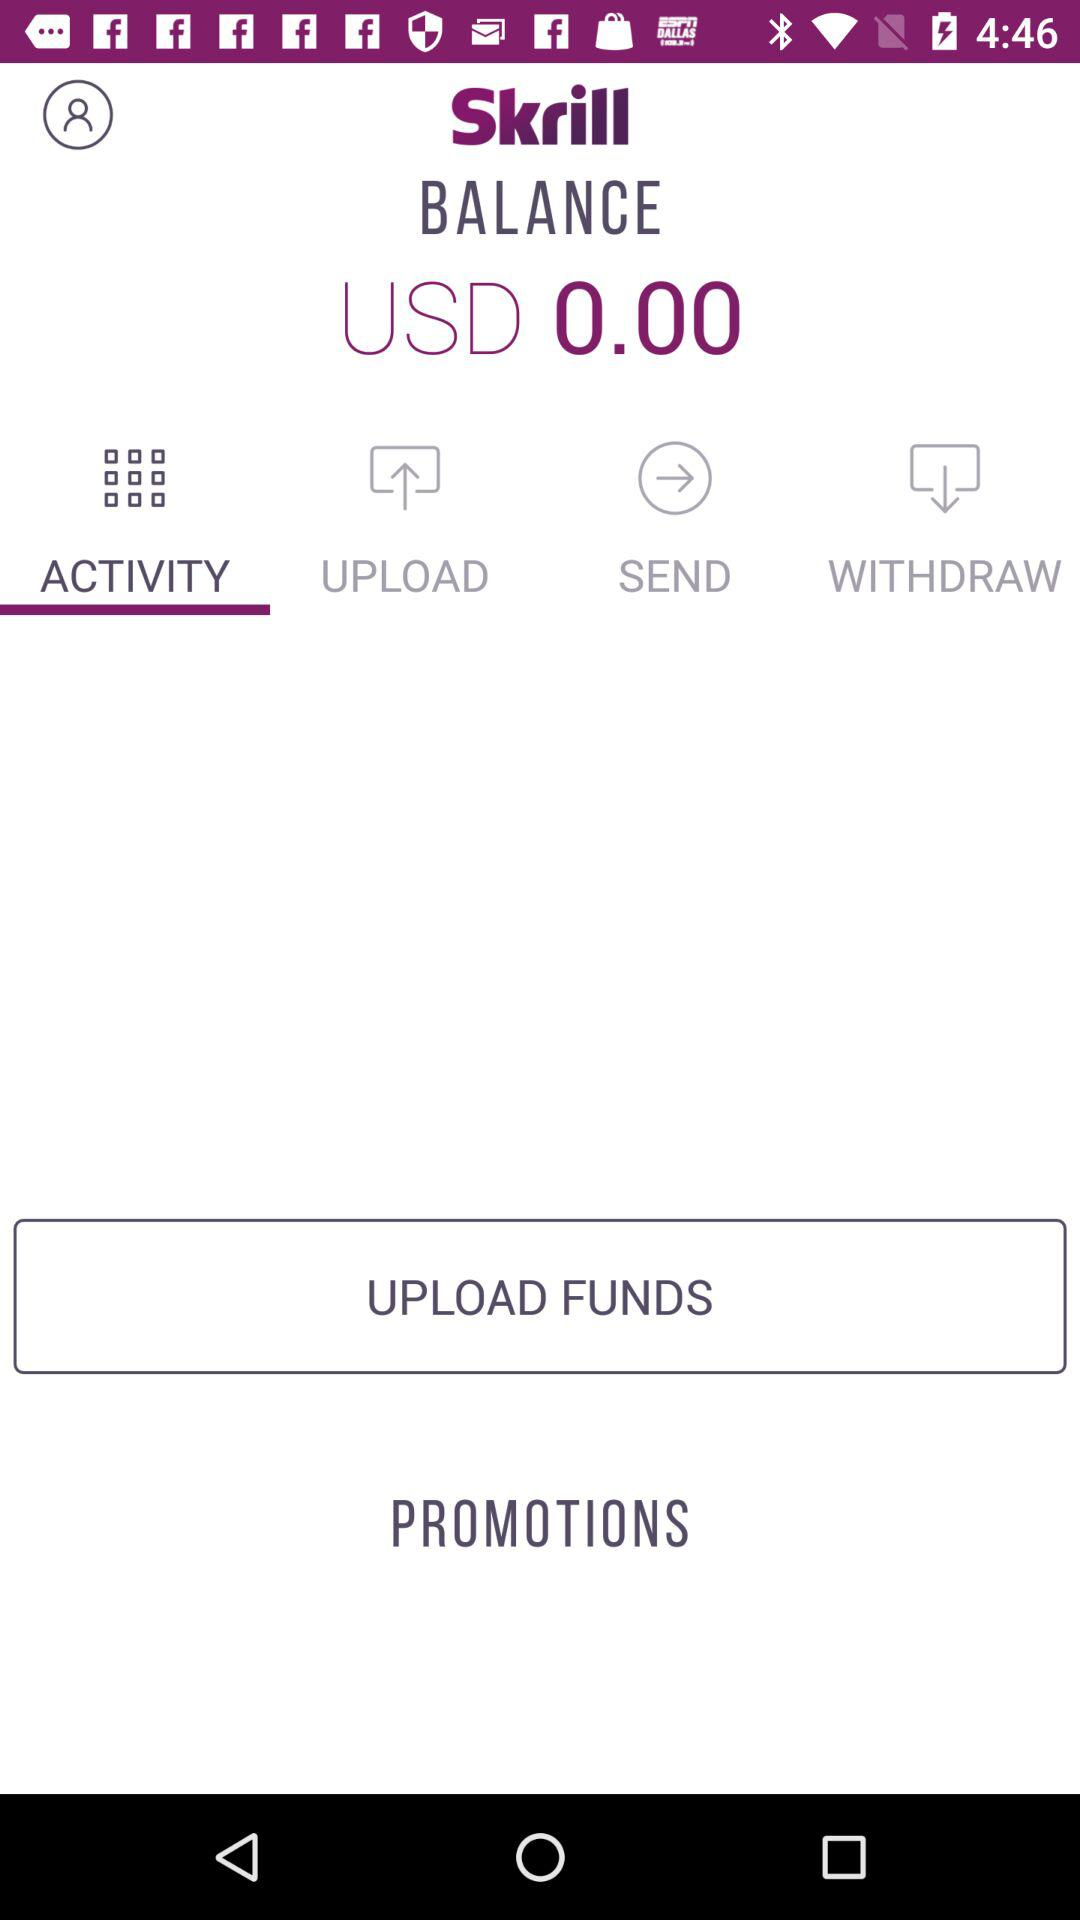What is the app name? The app name is "Skrill". 